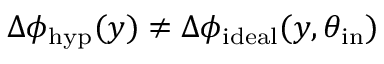<formula> <loc_0><loc_0><loc_500><loc_500>\Delta \phi _ { h y p } ( y ) \neq \Delta \phi _ { i d e a l } ( y , \theta _ { i n } )</formula> 